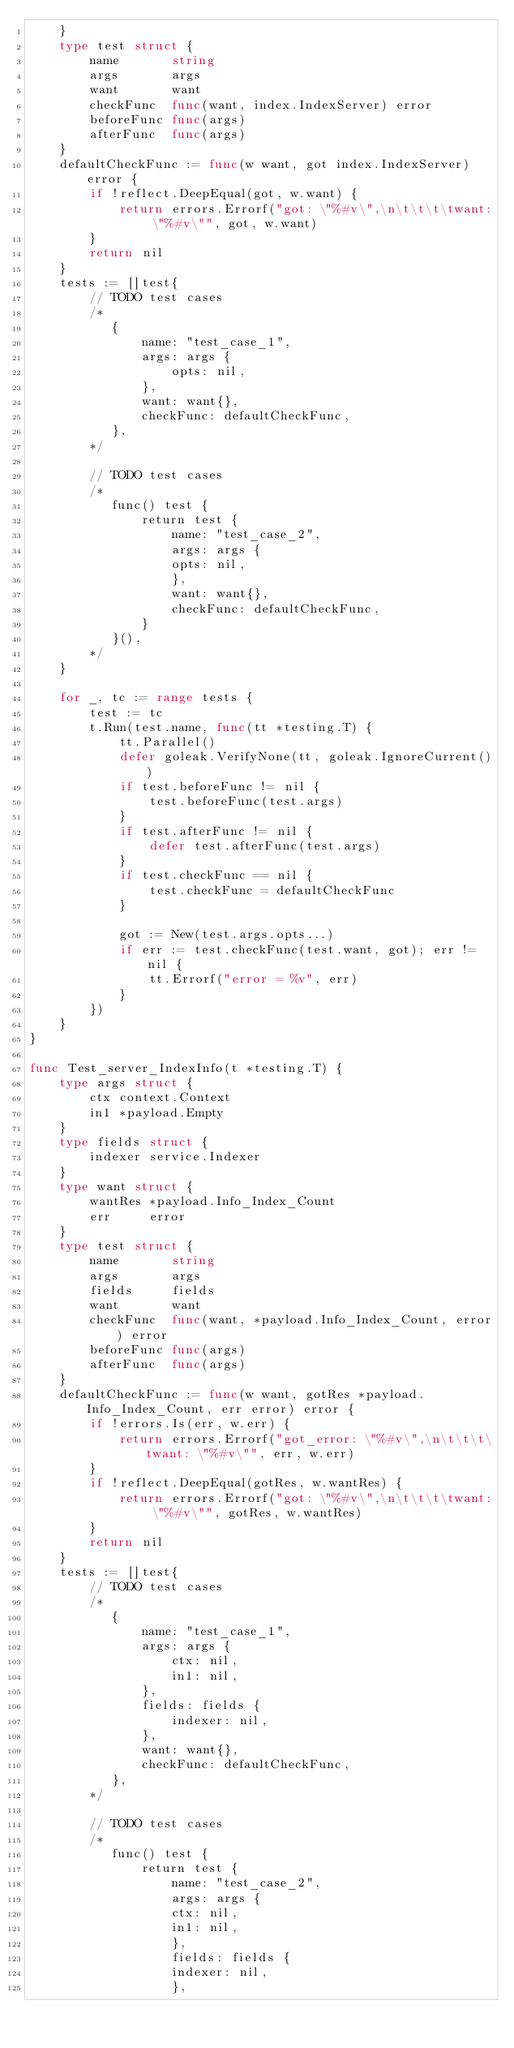<code> <loc_0><loc_0><loc_500><loc_500><_Go_>	}
	type test struct {
		name       string
		args       args
		want       want
		checkFunc  func(want, index.IndexServer) error
		beforeFunc func(args)
		afterFunc  func(args)
	}
	defaultCheckFunc := func(w want, got index.IndexServer) error {
		if !reflect.DeepEqual(got, w.want) {
			return errors.Errorf("got: \"%#v\",\n\t\t\t\twant: \"%#v\"", got, w.want)
		}
		return nil
	}
	tests := []test{
		// TODO test cases
		/*
		   {
		       name: "test_case_1",
		       args: args {
		           opts: nil,
		       },
		       want: want{},
		       checkFunc: defaultCheckFunc,
		   },
		*/

		// TODO test cases
		/*
		   func() test {
		       return test {
		           name: "test_case_2",
		           args: args {
		           opts: nil,
		           },
		           want: want{},
		           checkFunc: defaultCheckFunc,
		       }
		   }(),
		*/
	}

	for _, tc := range tests {
		test := tc
		t.Run(test.name, func(tt *testing.T) {
			tt.Parallel()
			defer goleak.VerifyNone(tt, goleak.IgnoreCurrent())
			if test.beforeFunc != nil {
				test.beforeFunc(test.args)
			}
			if test.afterFunc != nil {
				defer test.afterFunc(test.args)
			}
			if test.checkFunc == nil {
				test.checkFunc = defaultCheckFunc
			}

			got := New(test.args.opts...)
			if err := test.checkFunc(test.want, got); err != nil {
				tt.Errorf("error = %v", err)
			}
		})
	}
}

func Test_server_IndexInfo(t *testing.T) {
	type args struct {
		ctx context.Context
		in1 *payload.Empty
	}
	type fields struct {
		indexer service.Indexer
	}
	type want struct {
		wantRes *payload.Info_Index_Count
		err     error
	}
	type test struct {
		name       string
		args       args
		fields     fields
		want       want
		checkFunc  func(want, *payload.Info_Index_Count, error) error
		beforeFunc func(args)
		afterFunc  func(args)
	}
	defaultCheckFunc := func(w want, gotRes *payload.Info_Index_Count, err error) error {
		if !errors.Is(err, w.err) {
			return errors.Errorf("got_error: \"%#v\",\n\t\t\t\twant: \"%#v\"", err, w.err)
		}
		if !reflect.DeepEqual(gotRes, w.wantRes) {
			return errors.Errorf("got: \"%#v\",\n\t\t\t\twant: \"%#v\"", gotRes, w.wantRes)
		}
		return nil
	}
	tests := []test{
		// TODO test cases
		/*
		   {
		       name: "test_case_1",
		       args: args {
		           ctx: nil,
		           in1: nil,
		       },
		       fields: fields {
		           indexer: nil,
		       },
		       want: want{},
		       checkFunc: defaultCheckFunc,
		   },
		*/

		// TODO test cases
		/*
		   func() test {
		       return test {
		           name: "test_case_2",
		           args: args {
		           ctx: nil,
		           in1: nil,
		           },
		           fields: fields {
		           indexer: nil,
		           },</code> 